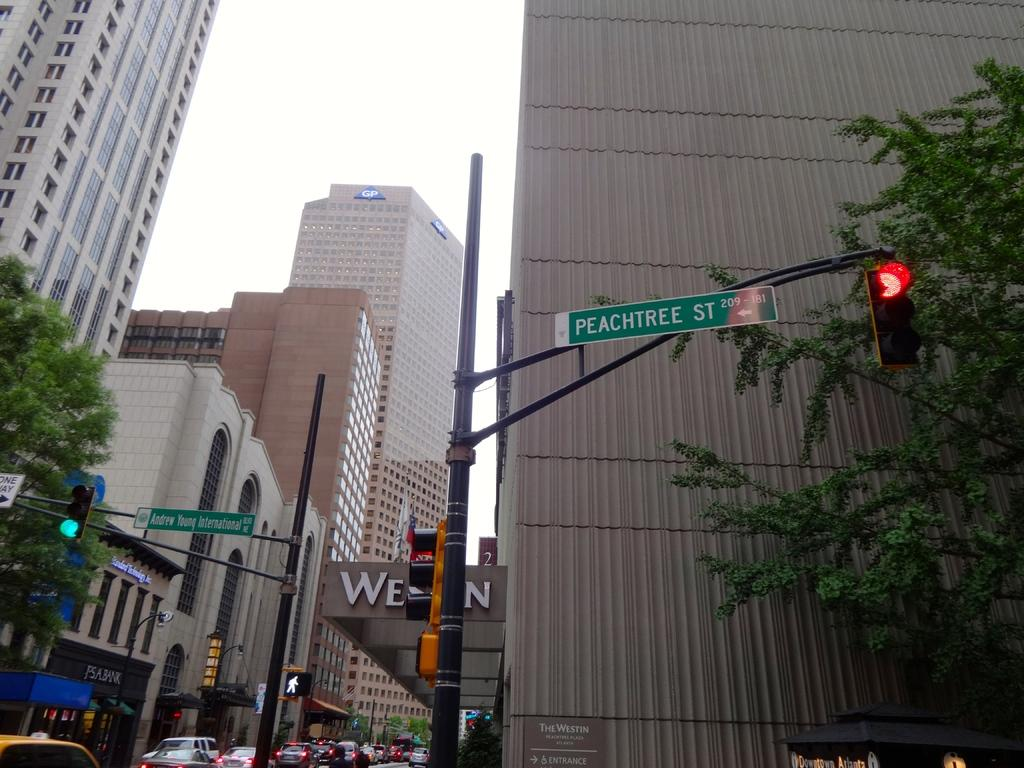<image>
Offer a succinct explanation of the picture presented. Several street signs line a city street up on posts and one says PEACHTREE ST. and the other says Andrew Young International rd. 